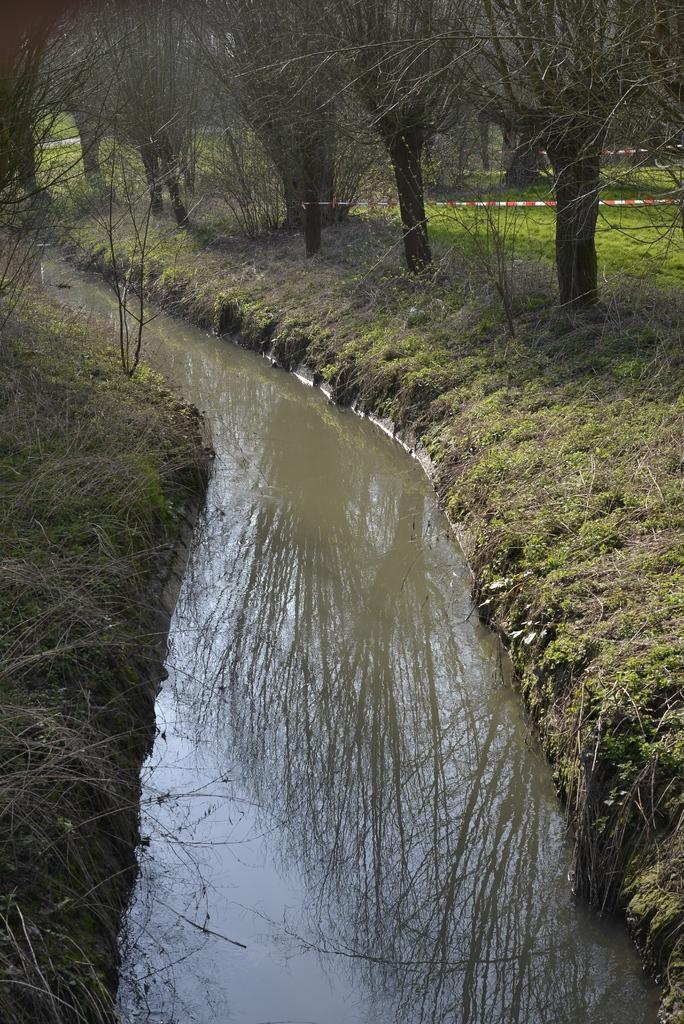Describe this image in one or two sentences. In the image there is a ditch and around the ditch there is grass and trees. 